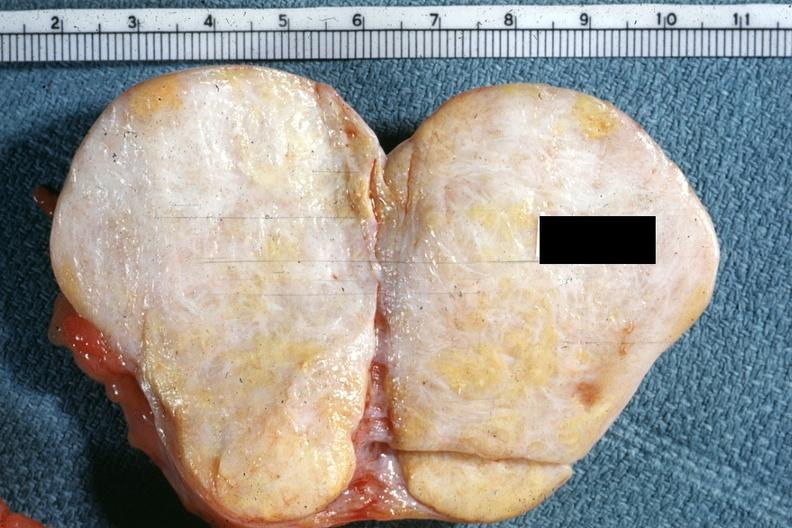s autopsy quite obvious?
Answer the question using a single word or phrase. No 